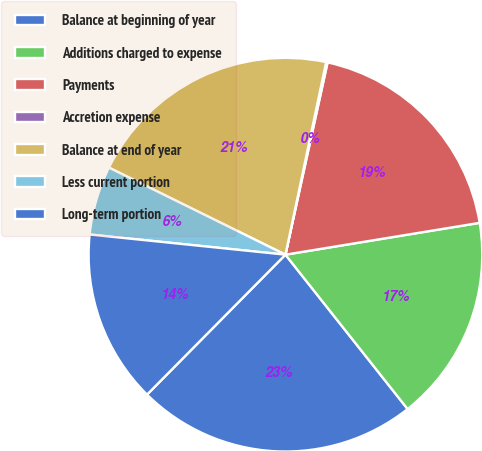Convert chart to OTSL. <chart><loc_0><loc_0><loc_500><loc_500><pie_chart><fcel>Balance at beginning of year<fcel>Additions charged to expense<fcel>Payments<fcel>Accretion expense<fcel>Balance at end of year<fcel>Less current portion<fcel>Long-term portion<nl><fcel>23.07%<fcel>16.93%<fcel>18.98%<fcel>0.12%<fcel>21.02%<fcel>5.66%<fcel>14.22%<nl></chart> 